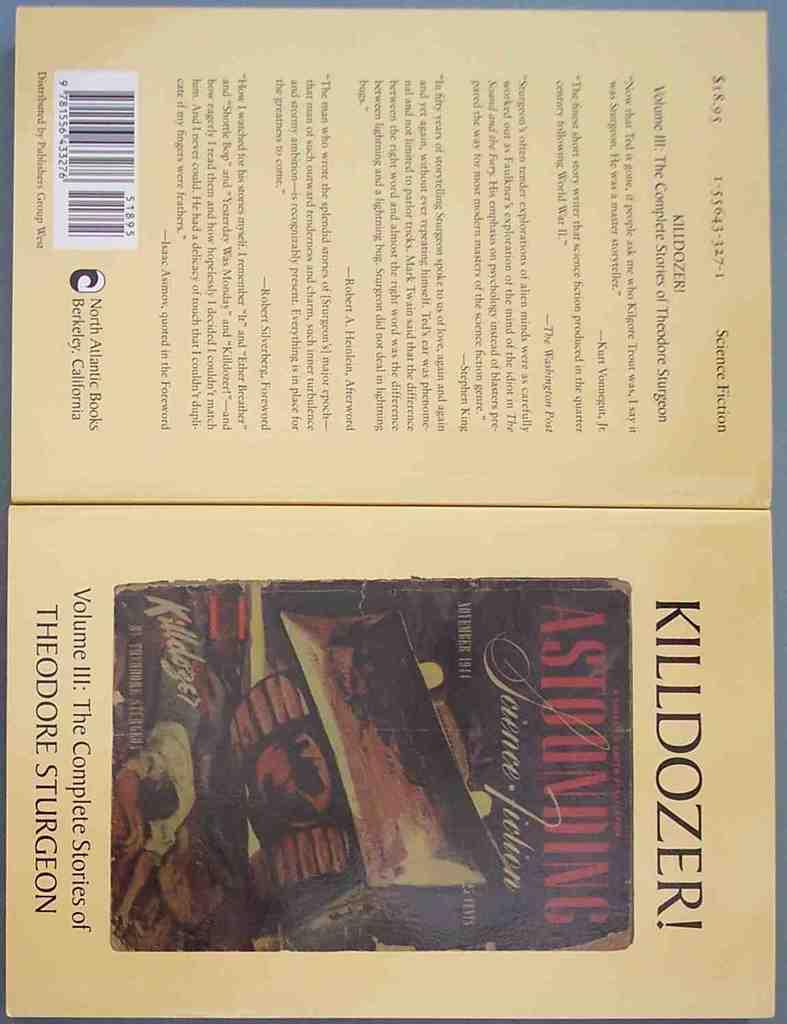Who is the author?
Provide a succinct answer. Theodore sturgeon. 